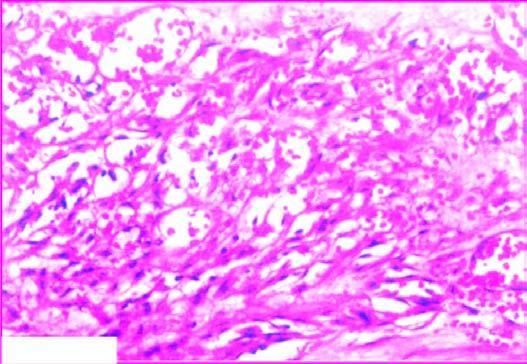re stored iron slit-like blood-filled vascular spaces?
Answer the question using a single word or phrase. No 